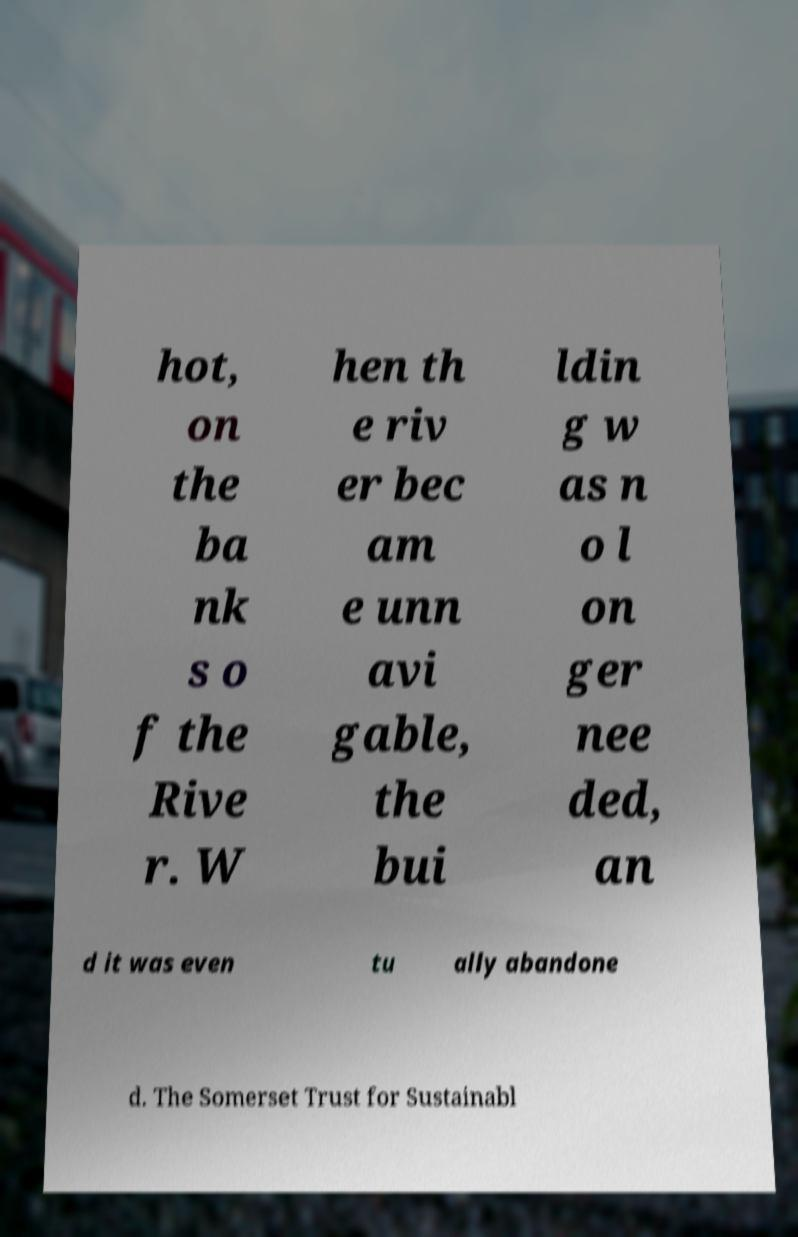What messages or text are displayed in this image? I need them in a readable, typed format. hot, on the ba nk s o f the Rive r. W hen th e riv er bec am e unn avi gable, the bui ldin g w as n o l on ger nee ded, an d it was even tu ally abandone d. The Somerset Trust for Sustainabl 